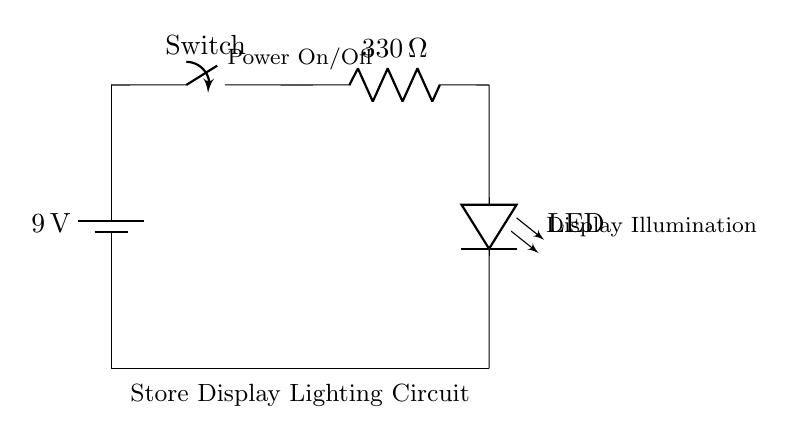What is the voltage of the battery? The circuit diagram indicates a battery labeled with a value of 9 volts, which is the source voltage for the entire circuit.
Answer: 9 volts What component acts as a switch in the circuit? The circuit diagram shows a component labeled as a "Switch," which is used to control the flow of current by either allowing or interrupting it.
Answer: Switch What is the resistance value of the resistor? The resistor in the circuit is labeled with a value of 330 ohms, indicating its resistance to the flow of electric current.
Answer: 330 ohms What is the purpose of the LED in this circuit? The LED is labeled as "LED" in the circuit diagram, indicating its role as a light-emitting diode that illuminates the store display when current flows through it.
Answer: Display illumination Why is a resistor included in this circuit? The resistor is necessary to limit the current flowing through the LED, preventing it from receiving too much current which could potentially damage it. This is important for safely operating the LED within its specified parameters.
Answer: To limit current What would happen if the switch is closed? Closing the switch completes the circuit, allowing current to flow from the battery, through the resistor, and finally to the LED, causing it to light up. Thus, the display would be illuminated.
Answer: The LED lights up What is the significance of grounding in this circuit? Grounding in the circuit provides a reference point for voltage measurements and ensures safety by directing any stray currents away, thus stabilizing the circuit operation and protecting components.
Answer: Safety and stability 